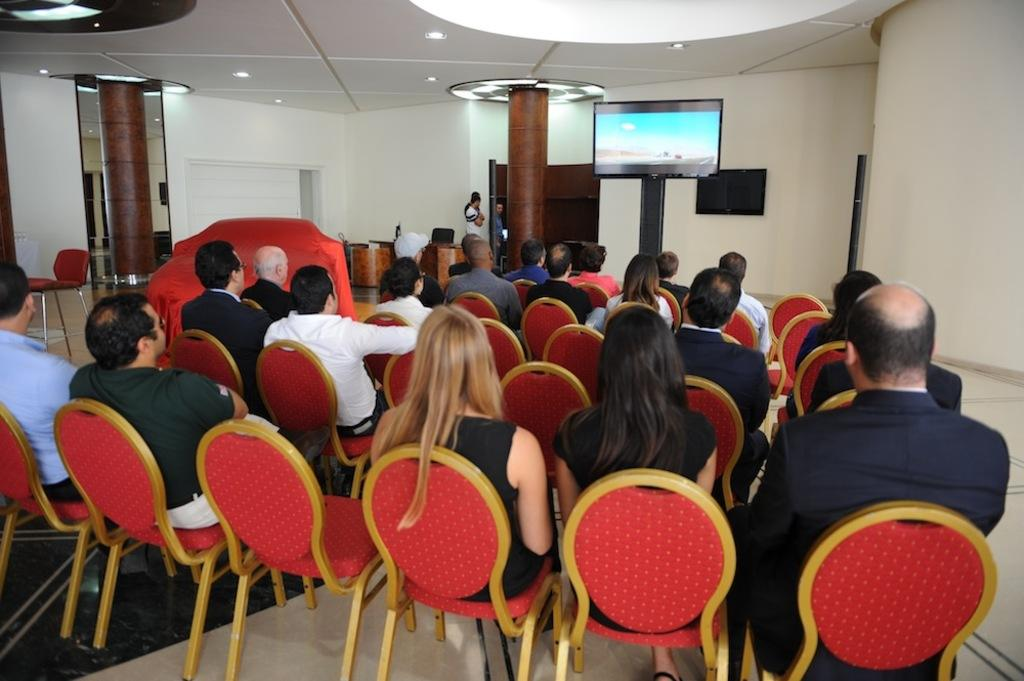What are the people in the image doing? There is a group of persons sitting on chairs in the image. What structure can be seen in the image? There is a pillar in the image. What electronic device is present in the image? There is a television in the image. Can you describe the position of a person in the image? A person is standing in the image. What type of architectural feature is visible in the image? There is a wall in the image. What type of fuel is being used by the brain in the image? There is no brain or fuel present in the image; it features a group of persons sitting on chairs, a pillar, a television, a standing person, and a wall. 